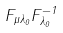<formula> <loc_0><loc_0><loc_500><loc_500>F _ { \mu \lambda _ { 0 } } F _ { \lambda _ { 0 } } ^ { - 1 }</formula> 